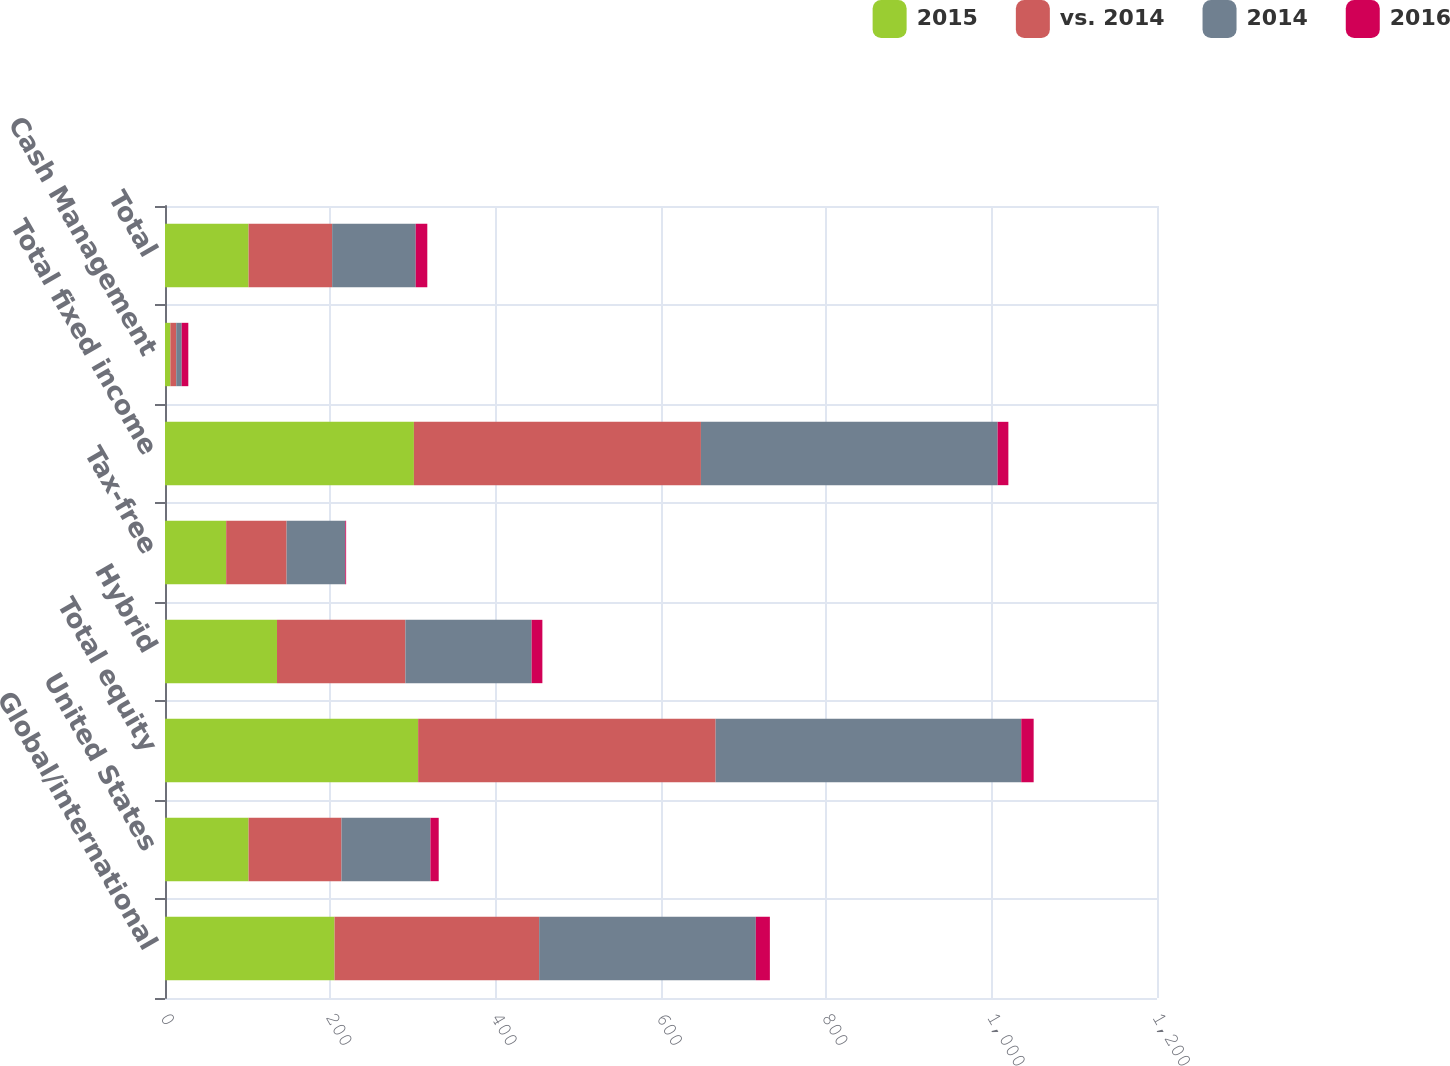Convert chart to OTSL. <chart><loc_0><loc_0><loc_500><loc_500><stacked_bar_chart><ecel><fcel>Global/international<fcel>United States<fcel>Total equity<fcel>Hybrid<fcel>Tax-free<fcel>Total fixed income<fcel>Cash Management<fcel>Total<nl><fcel>2015<fcel>205.1<fcel>101.1<fcel>306.2<fcel>135.5<fcel>74<fcel>301.1<fcel>6.5<fcel>101.1<nl><fcel>vs. 2014<fcel>247.5<fcel>112.4<fcel>359.9<fcel>155.3<fcel>73.1<fcel>347.2<fcel>7.1<fcel>101.1<nl><fcel>2014<fcel>262.1<fcel>107.6<fcel>369.7<fcel>152.7<fcel>71<fcel>358.9<fcel>6.6<fcel>101.1<nl><fcel>2016<fcel>17<fcel>10<fcel>15<fcel>13<fcel>1<fcel>13<fcel>8<fcel>14<nl></chart> 